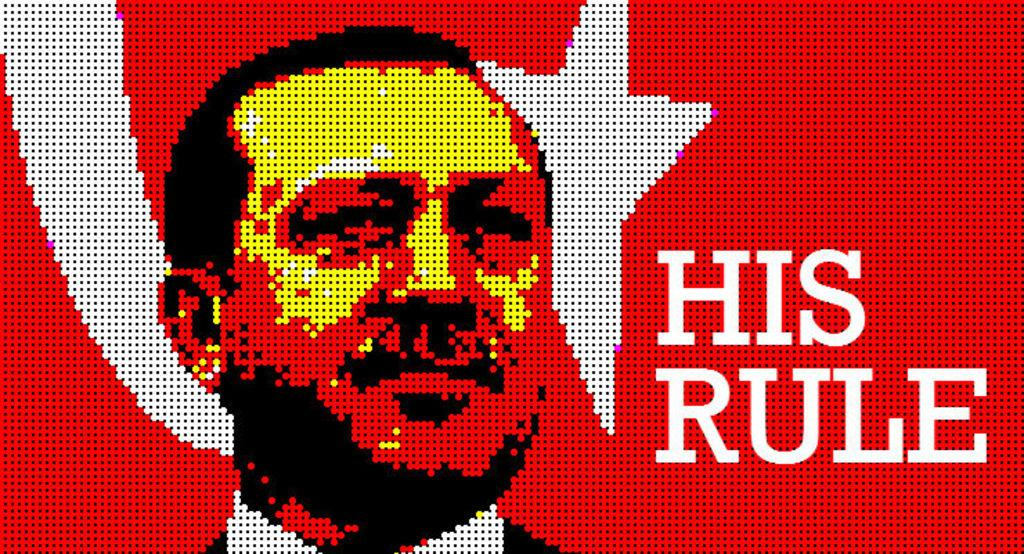<image>
Give a short and clear explanation of the subsequent image. A pixelated poster of a man that says His Rule. 